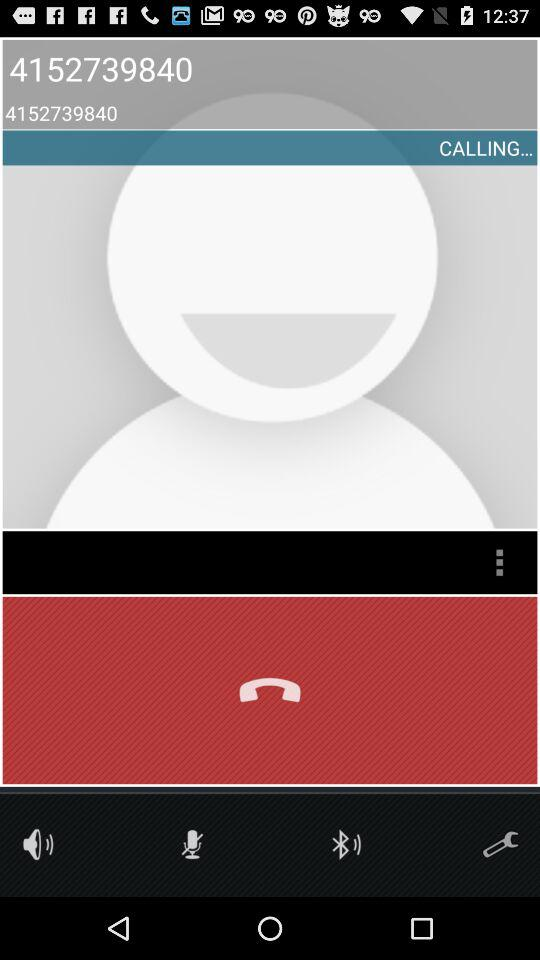How many digits are in the phone number?
Answer the question using a single word or phrase. 10 